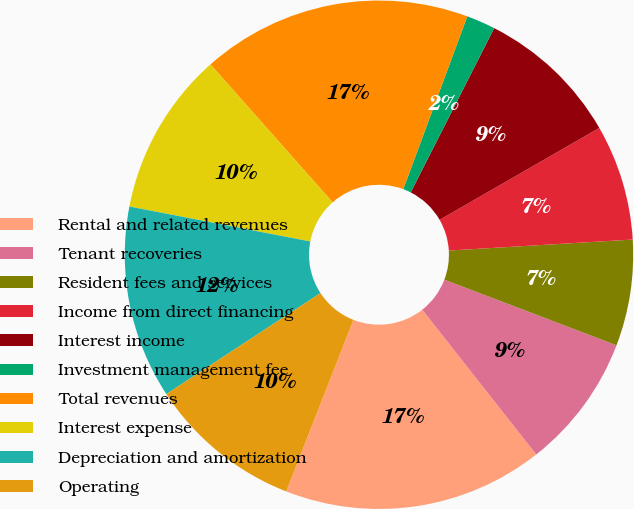Convert chart. <chart><loc_0><loc_0><loc_500><loc_500><pie_chart><fcel>Rental and related revenues<fcel>Tenant recoveries<fcel>Resident fees and services<fcel>Income from direct financing<fcel>Interest income<fcel>Investment management fee<fcel>Total revenues<fcel>Interest expense<fcel>Depreciation and amortization<fcel>Operating<nl><fcel>16.56%<fcel>8.59%<fcel>6.75%<fcel>7.36%<fcel>9.2%<fcel>1.84%<fcel>17.18%<fcel>10.43%<fcel>12.27%<fcel>9.82%<nl></chart> 